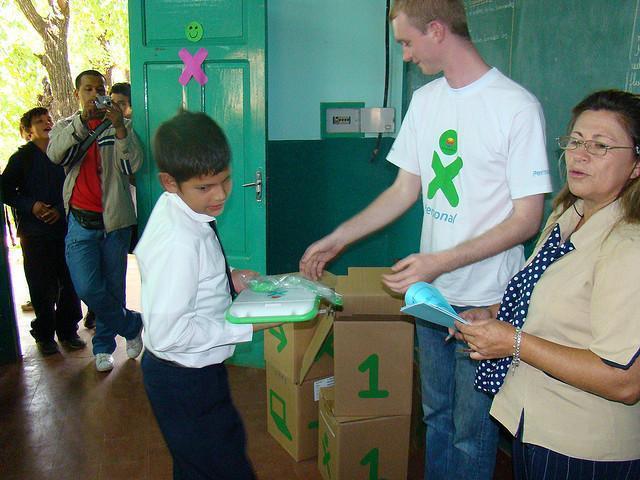How many people are in the photo?
Give a very brief answer. 5. 